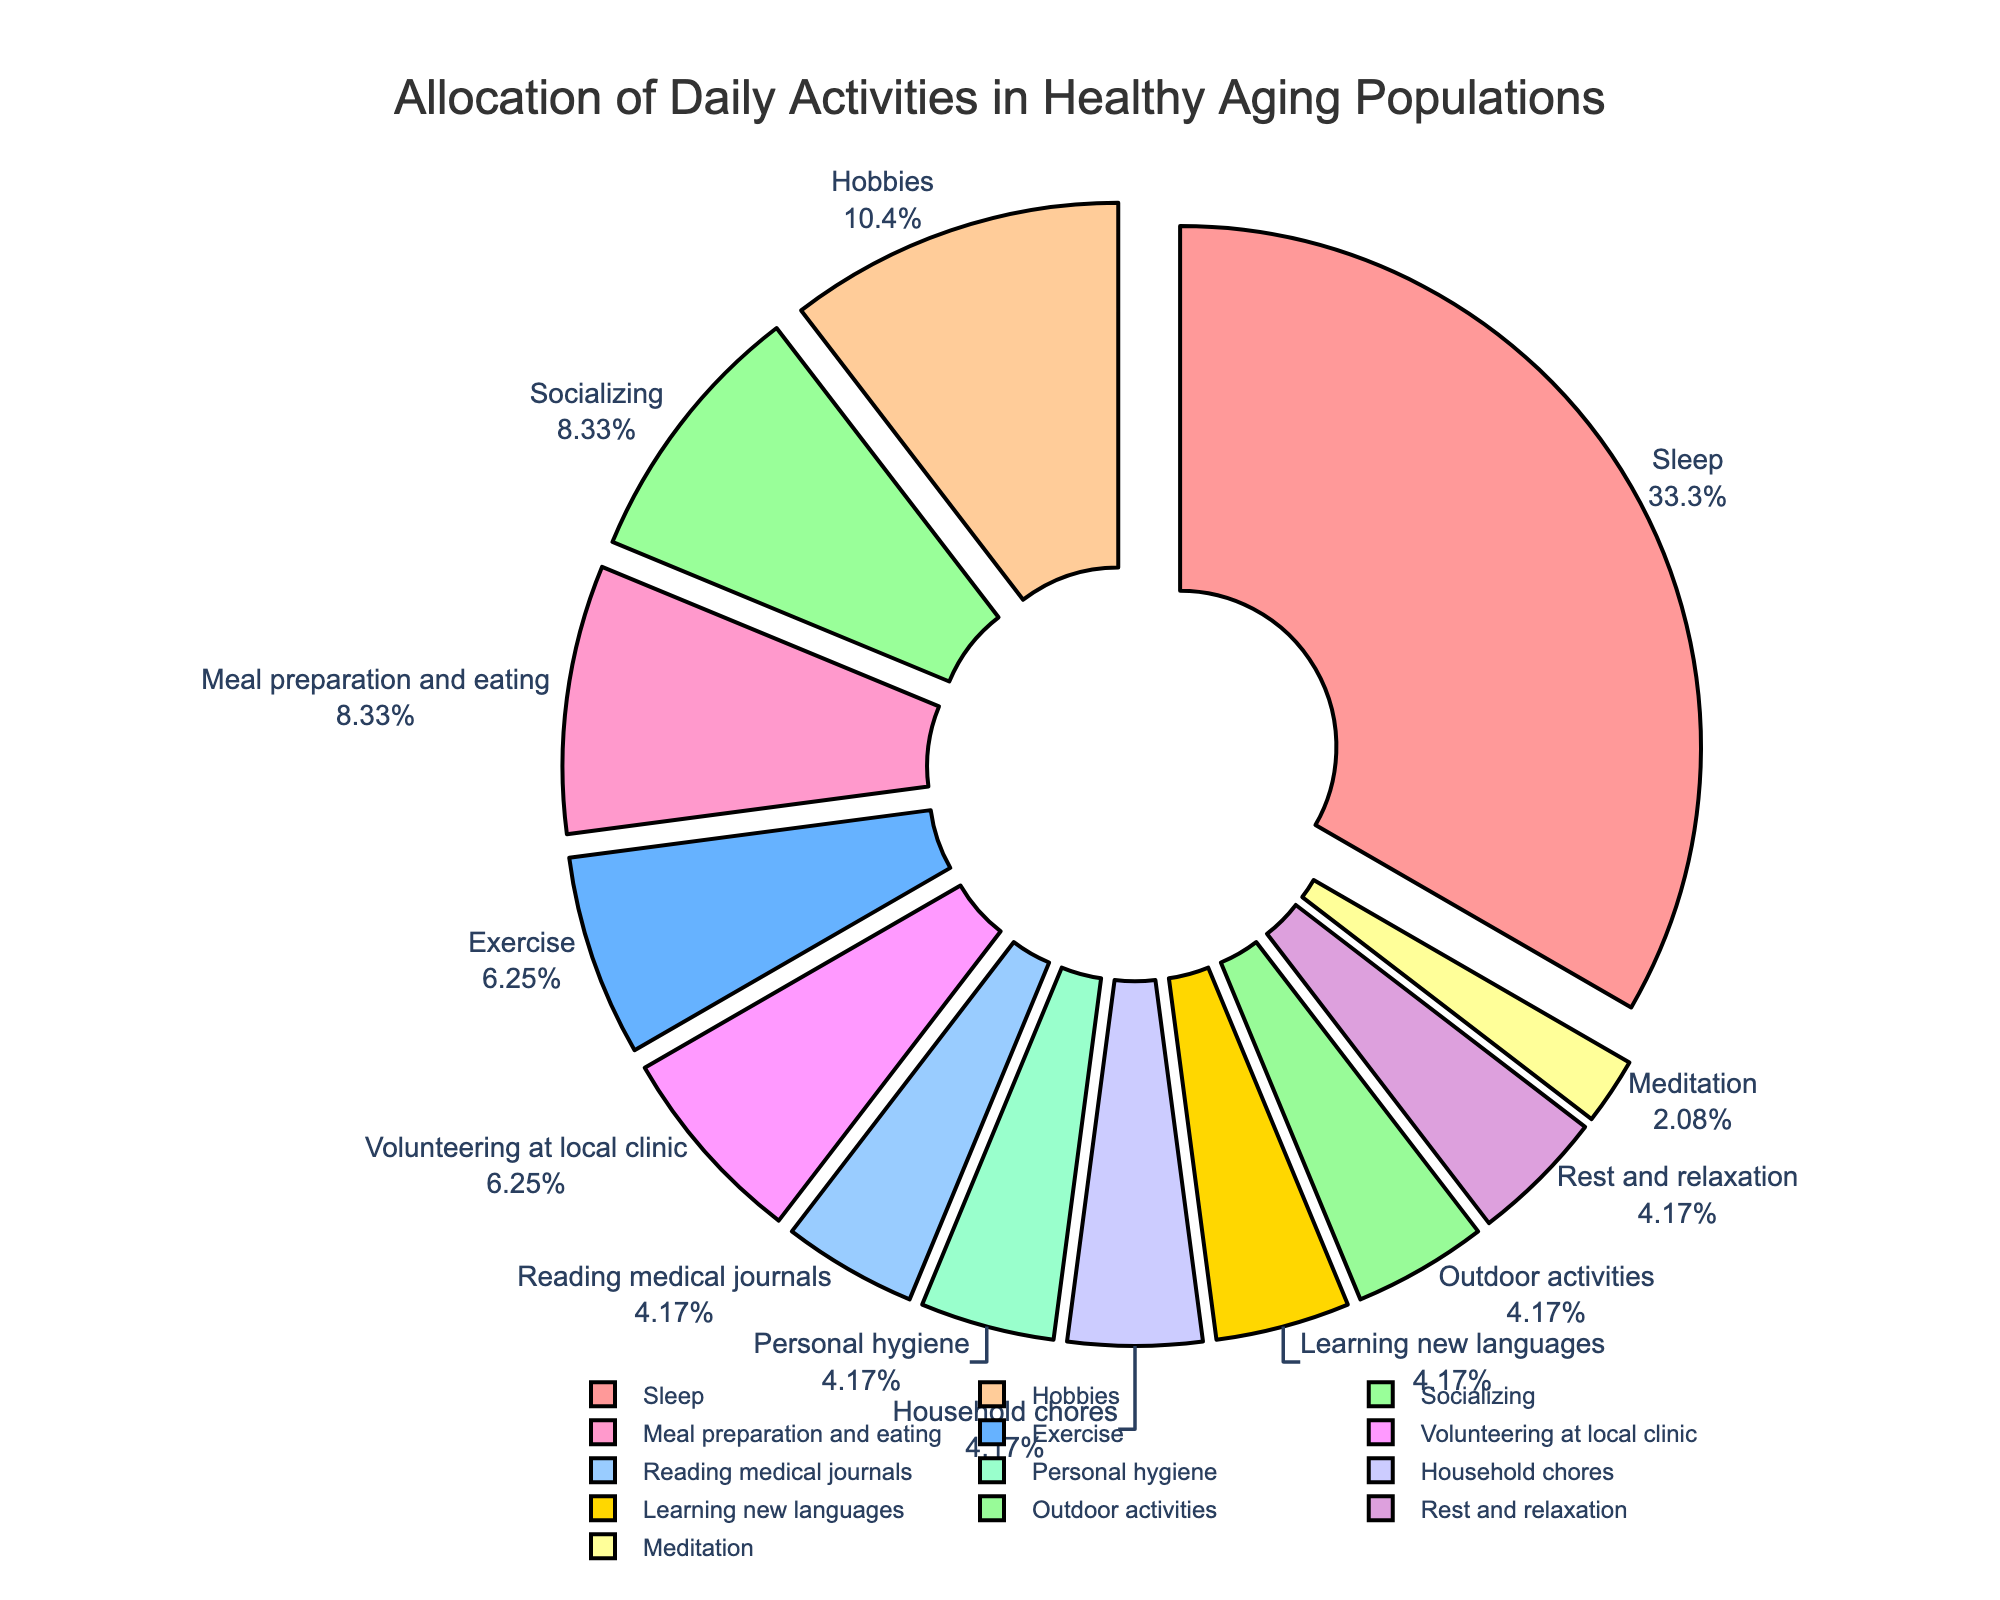What activity takes up the largest portion of the day? Look at the segment with the highest percentage in the pie chart. This activity is represented as "Sleep," which has the largest section.
Answer: Sleep Which activities combined equal the time spent sleeping? Look for activities whose total hours add up to 8 (the hours spent sleeping). Socializing, hobbies, meal preparation and eating, and volunteering at the clinic add up to (2 + 2.5 + 2 + 1.5 = 8 hours).
Answer: Socializing, hobbies, meal preparation and eating, and volunteering at the clinic Is more time allocated to exercise or socializing? Compare the segments for exercise and socializing. The exercise segment (1.5 hours) is smaller than the socializing segment (2 hours).
Answer: Socializing What percentage of the total daily activities is dedicated to hobbies? Identify the hobbies segment in the pie chart and note its percentage, which is approximately 10.42%.
Answer: 10.42% Which activity has the smallest segment in the pie chart? Identify the smallest segment visually in the pie chart, which is "Meditation" with 0.5 hours.
Answer: Meditation How does the time spent on meal preparation and eating compare to reading medical journals? Compare the segments; meal preparation and eating is allocated 2 hours, while reading medical journals is allocated 1 hour. Thus, meal preparation and eating takes up more time.
Answer: Meal preparation and eating Which activities have an equal amount of time allocated to them? Identify segments with the same number of hours. Personal hygiene, household chores, learning new languages, and outdoor activities all have 1 hour each.
Answer: Personal hygiene, household chores, learning new languages, and outdoor activities If you sum the time spent on meditation, reading medical journals, and learning new languages, what do you get? Sum the hours for these activities: meditation (0.5) + reading medical journals (1) + learning new languages (1), resulting in 2.5 hours.
Answer: 2.5 hours How many hours, in total, are allocated to rest and relaxation, hygiene, and household chores? Add the hours from these activities: rest and relaxation (1) + personal hygiene (1) + household chores (1), resulting in 3 hours.
Answer: 3 hours Does more time get spent on volunteering at the local clinic or outdoor activities? Compare the segments for volunteering at the local clinic and outdoor activities. Volunteering is allotted 1.5 hours, while outdoor activities are allotted 1 hour.
Answer: Volunteering at the local clinic 